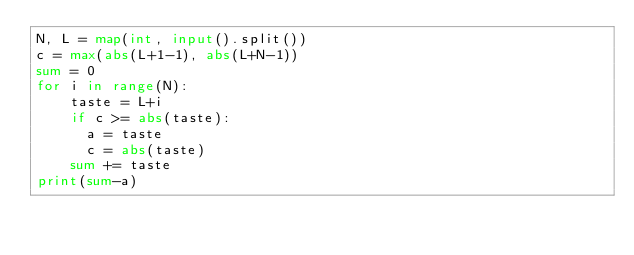Convert code to text. <code><loc_0><loc_0><loc_500><loc_500><_Python_>N, L = map(int, input().split())
c = max(abs(L+1-1), abs(L+N-1))
sum = 0
for i in range(N):
    taste = L+i  
    if c >= abs(taste):
      a = taste
      c = abs(taste)
    sum += taste 
print(sum-a)</code> 